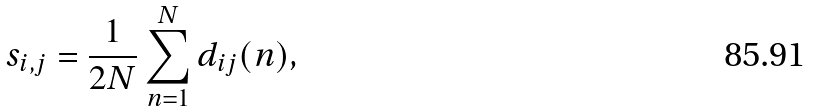Convert formula to latex. <formula><loc_0><loc_0><loc_500><loc_500>s _ { i , j } = \frac { 1 } { 2 N } \sum _ { n = 1 } ^ { N } d _ { i j } ( n ) ,</formula> 